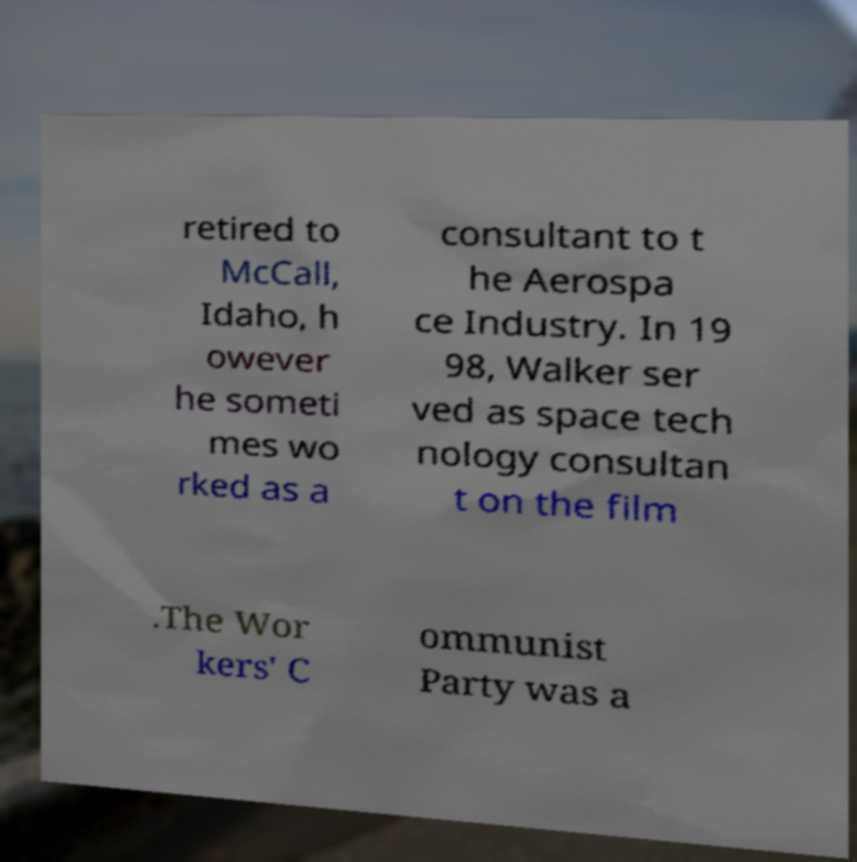For documentation purposes, I need the text within this image transcribed. Could you provide that? retired to McCall, Idaho, h owever he someti mes wo rked as a consultant to t he Aerospa ce Industry. In 19 98, Walker ser ved as space tech nology consultan t on the film .The Wor kers' C ommunist Party was a 